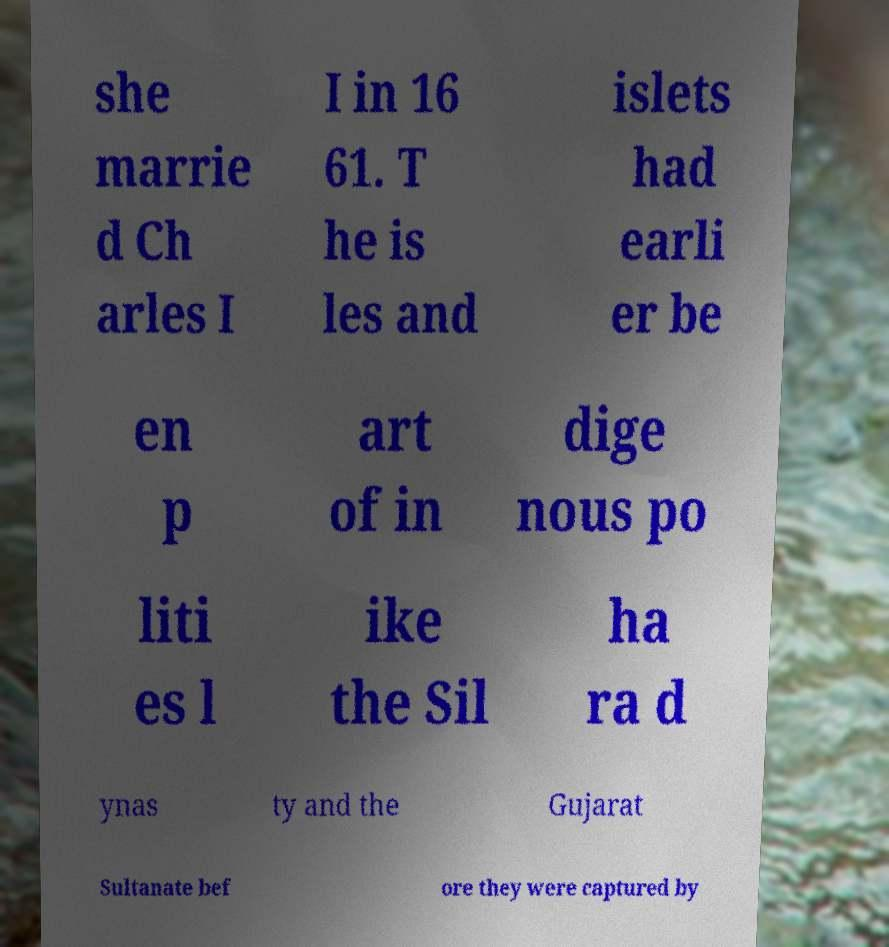Could you extract and type out the text from this image? she marrie d Ch arles I I in 16 61. T he is les and islets had earli er be en p art of in dige nous po liti es l ike the Sil ha ra d ynas ty and the Gujarat Sultanate bef ore they were captured by 